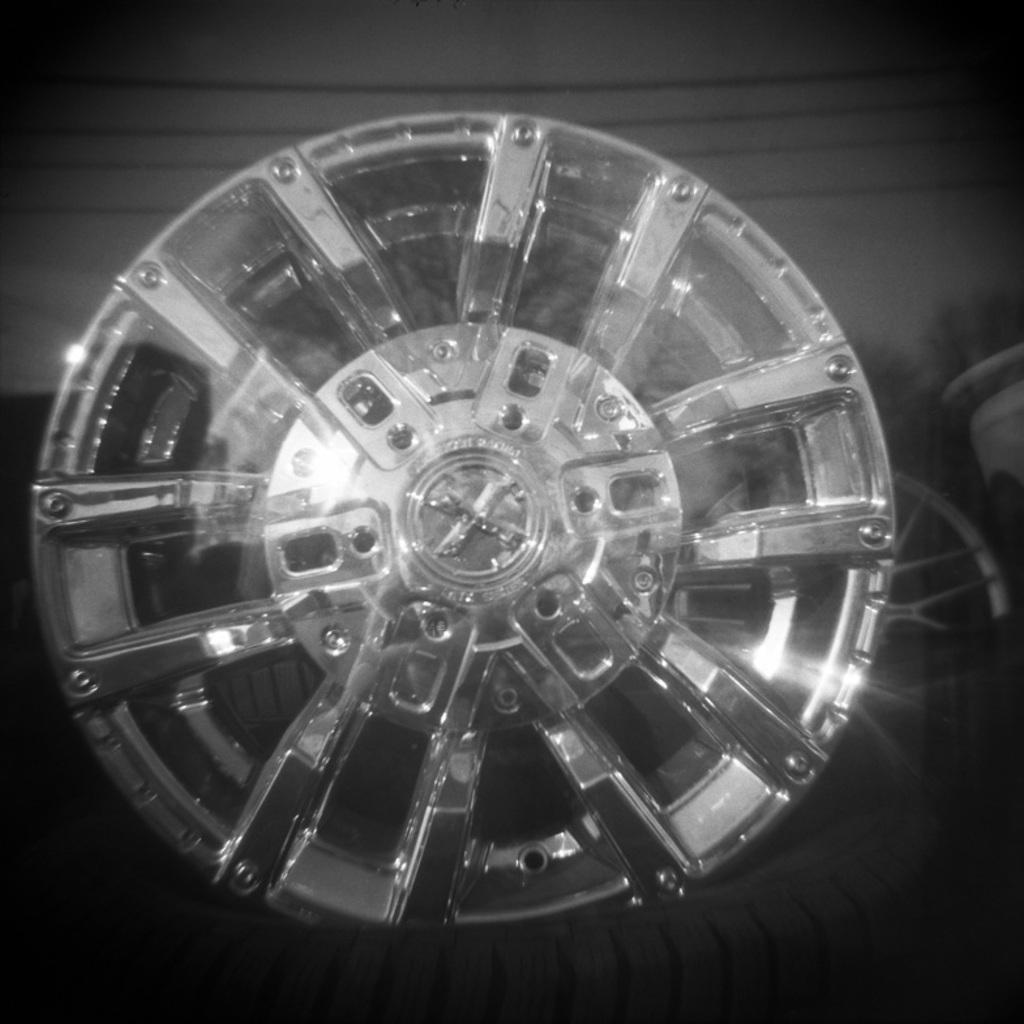Please provide a concise description of this image. In this image we can see one round object looks like a wheel, one white object in the background and some objects on the ground. 